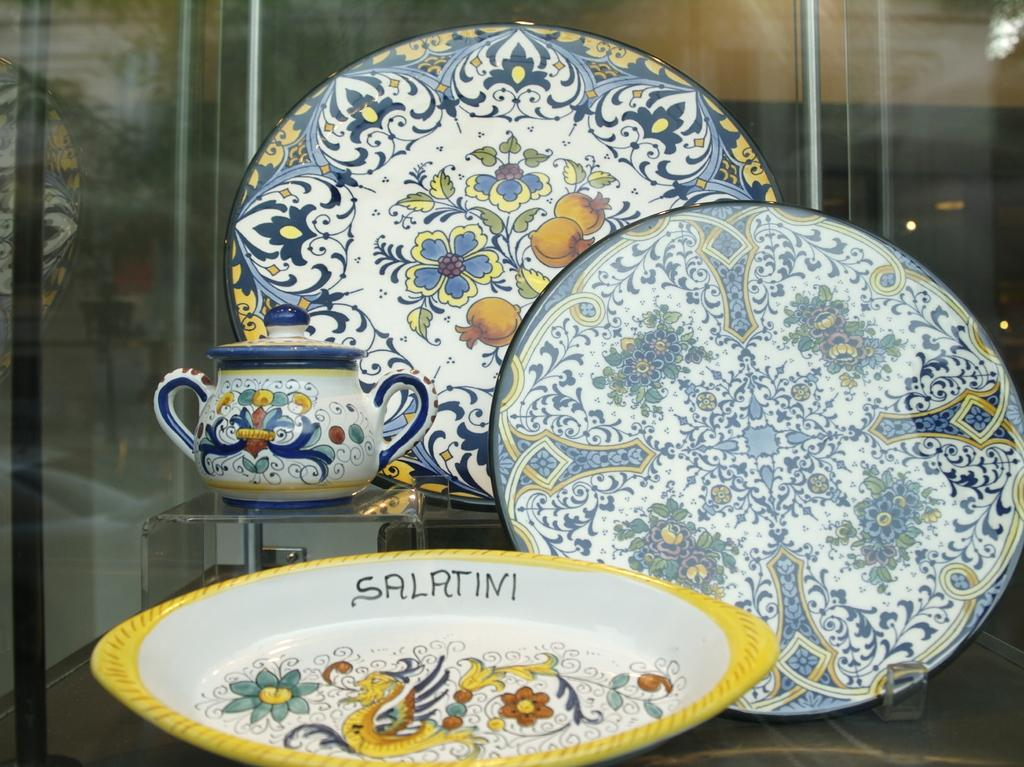What objects in the image have designs on them? The trays and jar in the image have designs on them. How many trays are visible in the image? The number of trays is not specified, but there are trays present in the image. What type of container is depicted in the image? There is a jar in the image. What grade does the pan receive in the image? There is no pan present in the image, so it cannot receive a grade. 